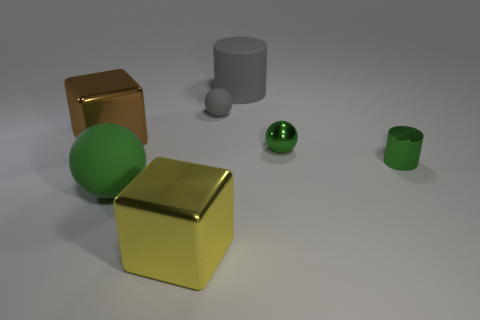Are there more metal spheres that are in front of the small cylinder than big gray objects right of the big gray cylinder?
Your answer should be compact. No. Is the big cylinder made of the same material as the small green cylinder?
Give a very brief answer. No. There is a cylinder in front of the large brown shiny thing; how many metal balls are to the right of it?
Provide a succinct answer. 0. Is the color of the cylinder that is behind the gray ball the same as the small metal ball?
Your response must be concise. No. What number of things are large brown metal blocks or large gray rubber objects that are to the right of the big ball?
Make the answer very short. 2. There is a large metal thing that is to the right of the brown block; does it have the same shape as the big rubber thing that is to the right of the big green sphere?
Keep it short and to the point. No. Is there any other thing that is the same color as the small rubber sphere?
Your response must be concise. Yes. There is a small thing that is the same material as the big green object; what is its shape?
Ensure brevity in your answer.  Sphere. What is the large thing that is both in front of the small green shiny cylinder and left of the yellow shiny object made of?
Make the answer very short. Rubber. Is there any other thing that is the same size as the gray matte sphere?
Provide a succinct answer. Yes. 